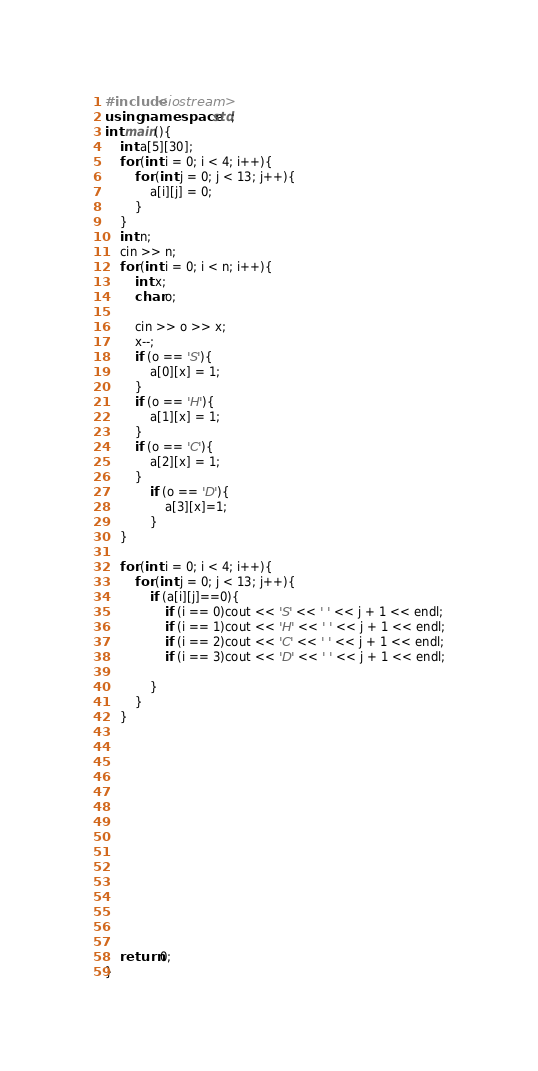<code> <loc_0><loc_0><loc_500><loc_500><_C++_>#include<iostream>
using namespace std;
int main(){
	int a[5][30];
	for (int i = 0; i < 4; i++){
		for (int j = 0; j < 13; j++){
			a[i][j] = 0;
		}
	}
	int n;
	cin >> n;
	for (int i = 0; i < n; i++){
		int x;
		char o;

		cin >> o >> x;
		x--;
		if (o == 'S'){
			a[0][x] = 1;
		}
		if (o == 'H'){
			a[1][x] = 1;
		}
		if (o == 'C'){
			a[2][x] = 1;
		}
			if (o == 'D'){
				a[3][x]=1;
			}
	}
	
	for (int i = 0; i < 4; i++){
		for (int j = 0; j < 13; j++){
			if (a[i][j]==0){
				if (i == 0)cout << 'S' << ' ' << j + 1 << endl;
				if (i == 1)cout << 'H' << ' ' << j + 1 << endl;
				if (i == 2)cout << 'C' << ' ' << j + 1 << endl;
				if (i == 3)cout << 'D' << ' ' << j + 1 << endl;

			}
		}
	}















	return 0;
}</code> 